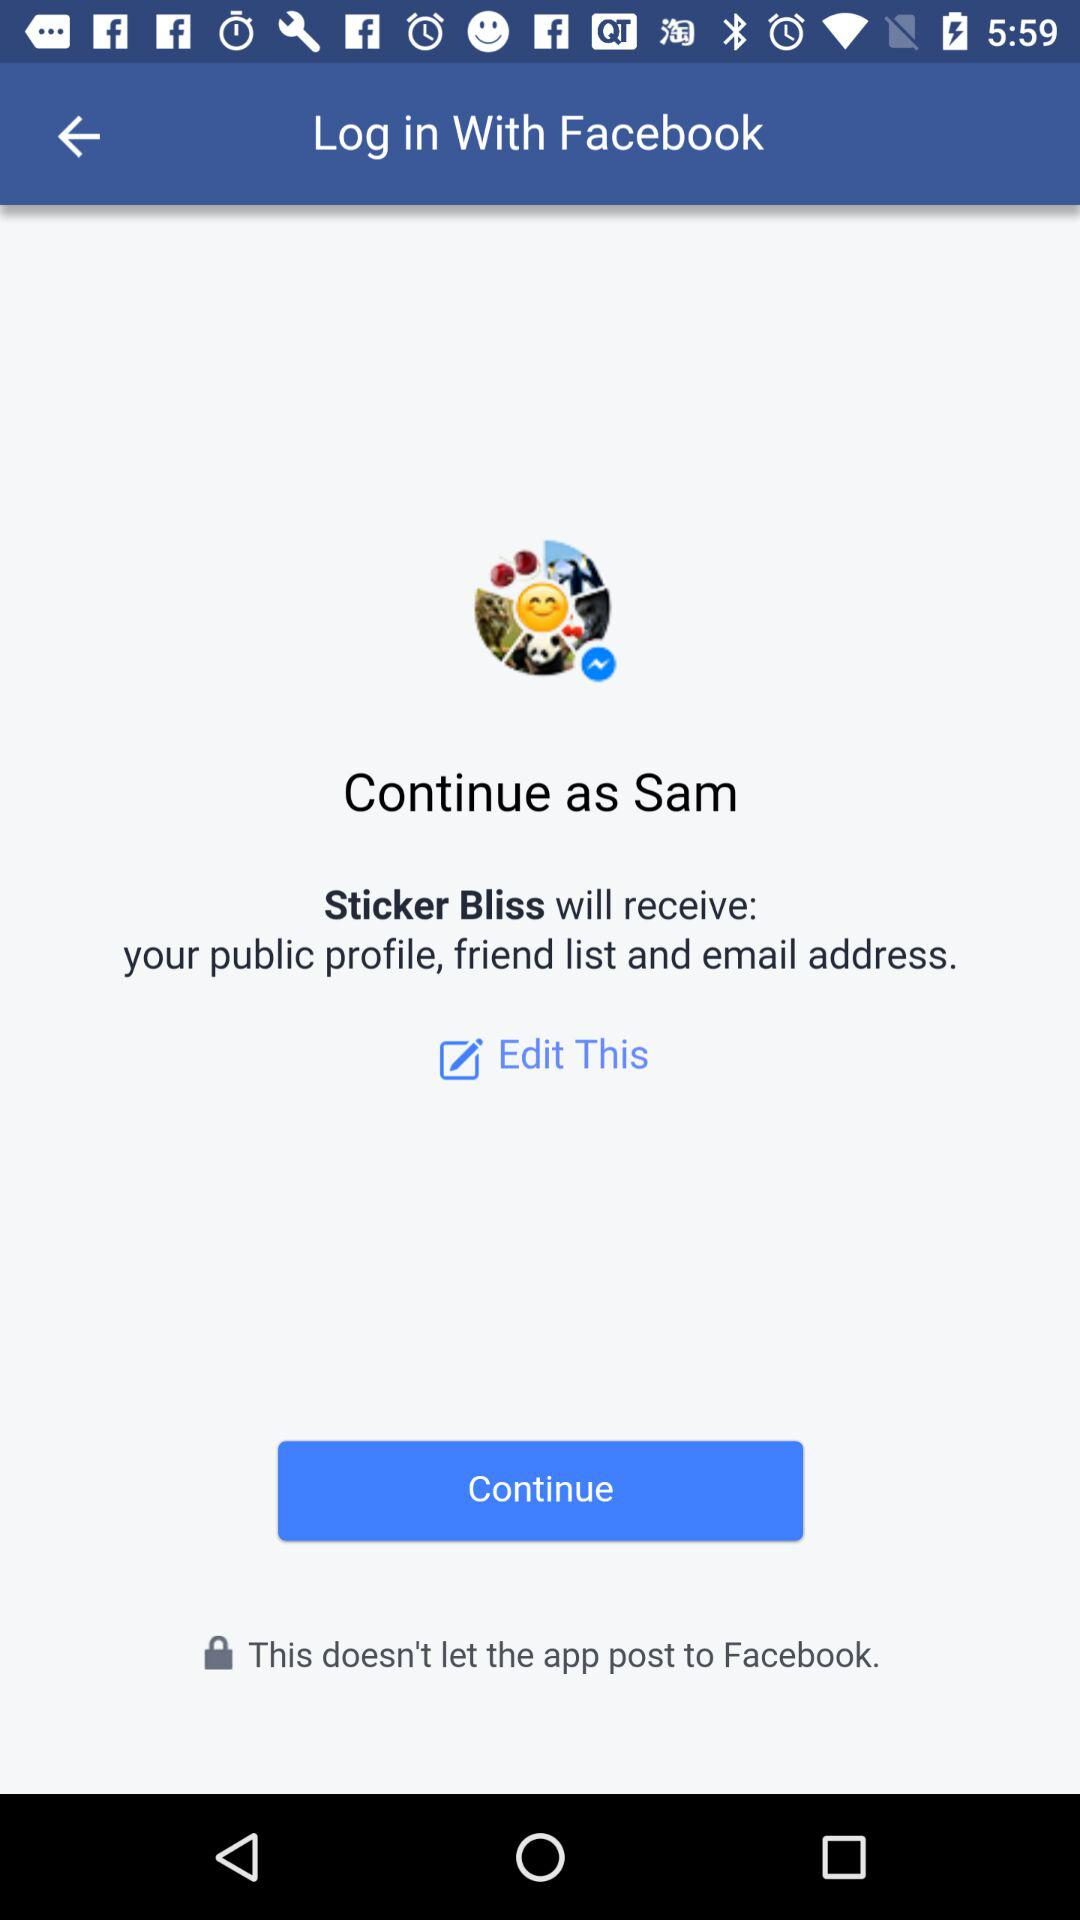Which application is asking for permissions? The application is "Facebook". 